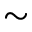Convert formula to latex. <formula><loc_0><loc_0><loc_500><loc_500>\sim</formula> 